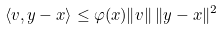<formula> <loc_0><loc_0><loc_500><loc_500>\langle v , y - x \rangle \leq \varphi ( x ) \| v \| \, \| y - x \| ^ { 2 }</formula> 